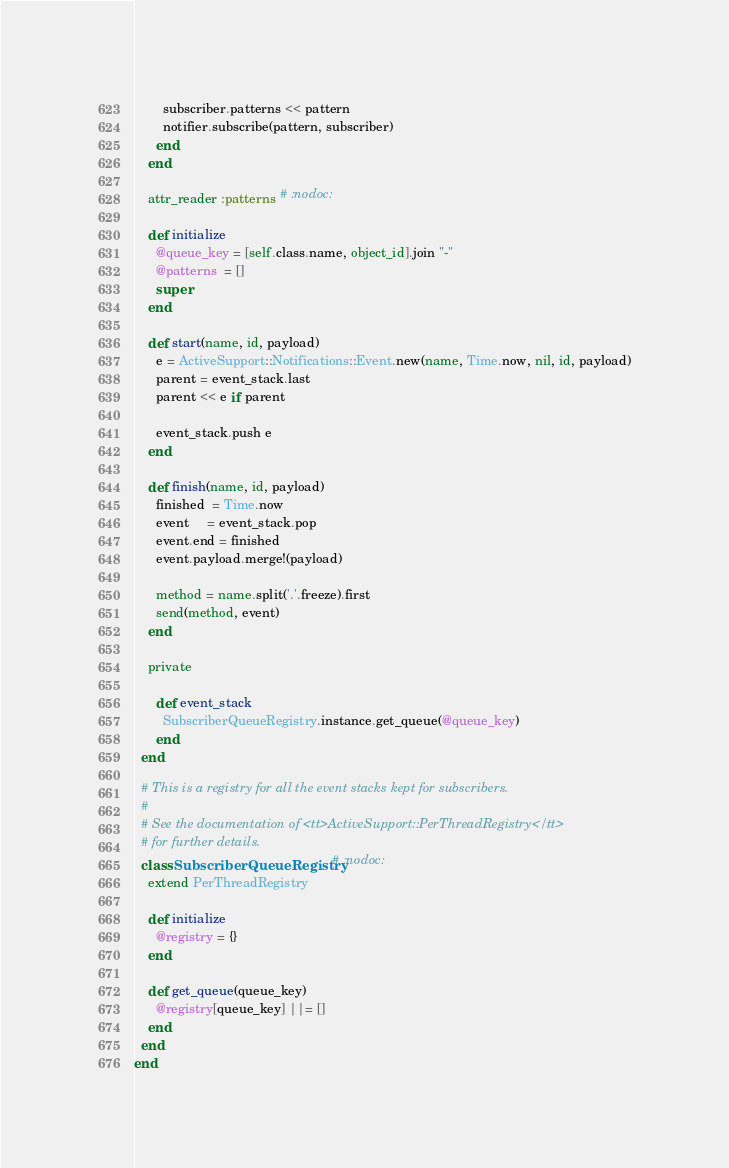Convert code to text. <code><loc_0><loc_0><loc_500><loc_500><_Ruby_>
        subscriber.patterns << pattern
        notifier.subscribe(pattern, subscriber)
      end
    end

    attr_reader :patterns # :nodoc:

    def initialize
      @queue_key = [self.class.name, object_id].join "-"
      @patterns  = []
      super
    end

    def start(name, id, payload)
      e = ActiveSupport::Notifications::Event.new(name, Time.now, nil, id, payload)
      parent = event_stack.last
      parent << e if parent

      event_stack.push e
    end

    def finish(name, id, payload)
      finished  = Time.now
      event     = event_stack.pop
      event.end = finished
      event.payload.merge!(payload)

      method = name.split('.'.freeze).first
      send(method, event)
    end

    private

      def event_stack
        SubscriberQueueRegistry.instance.get_queue(@queue_key)
      end
  end

  # This is a registry for all the event stacks kept for subscribers.
  #
  # See the documentation of <tt>ActiveSupport::PerThreadRegistry</tt>
  # for further details.
  class SubscriberQueueRegistry # :nodoc:
    extend PerThreadRegistry

    def initialize
      @registry = {}
    end

    def get_queue(queue_key)
      @registry[queue_key] ||= []
    end
  end
end
</code> 